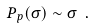Convert formula to latex. <formula><loc_0><loc_0><loc_500><loc_500>P _ { p } ( \sigma ) \sim \sigma \ .</formula> 